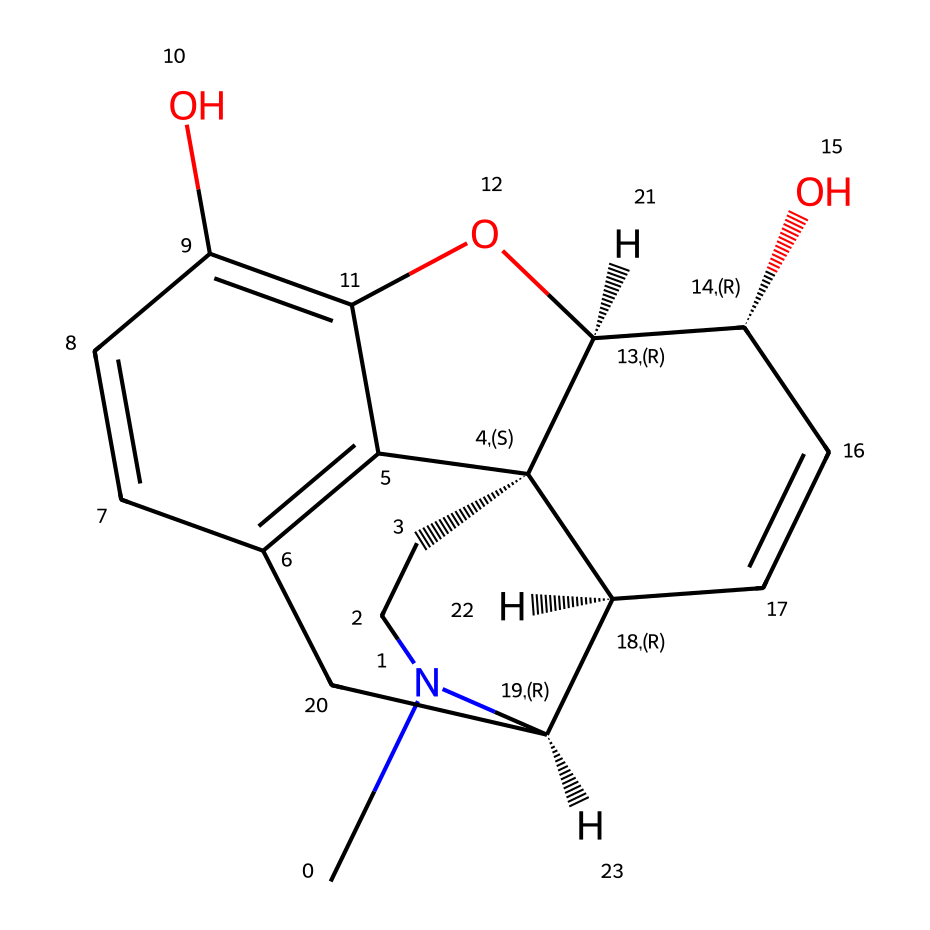how many carbon atoms are in the molecule? To determine the number of carbon atoms in the molecule, one must identify the carbon atoms represented in the structure. Each 'C' in the SMILES representation corresponds to a carbon atom. By counting each 'C', we find there are 17 carbon atoms in total.
Answer: 17 what is the functional group present in morphine? The functional group can be identified by looking for specific atoms and structures in the chemical (such as -OH for alcohols, -NH for amines). In the case of morphine, there are hydroxyl (alcohol) groups evident in the structure. Therefore, the primary functional group is the hydroxyl group.
Answer: hydroxyl how many rings are present in the morphine structure? To determine the number of rings in the structure, one must visualize or analyze the connections between the carbon atoms. In morphine, there are three fused rings in the structure. This can be deduced by examining the cyclic portions of the chemical's framework.
Answer: 3 is morphine a natural or synthetic compound? Morphine is classified based on its origin. By examining historical information, it's known that morphine is derived from opium poppy, which makes it a natural compound rather than synthetic.
Answer: natural what type of molecule is morphine classified as? Morphine is classified based on its chemical structure and function. Given its structure and its role as a pain-reliever, it falls under the category of alkaloids, which are nitrogen-containing compounds known for their pharmacological effects.
Answer: alkaloid what is the molecular formula of morphine? To derive the molecular formula, one needs to count the number of each type of atom within the morphine structure. After counting the atoms, the molecular formula can be deduced as C17H19NO3, where the numbers indicate the quantity of each atom present.
Answer: C17H19NO3 which chiral centers are present in morphine? Chiral centers can be identified in the structure where a carbon atom is connected to four different groups. In the structure of morphine, there are five carbon atoms that serve as chiral centers. This is evident through the unique attachments at each of these centers when analyzing the structure in detail.
Answer: 5 